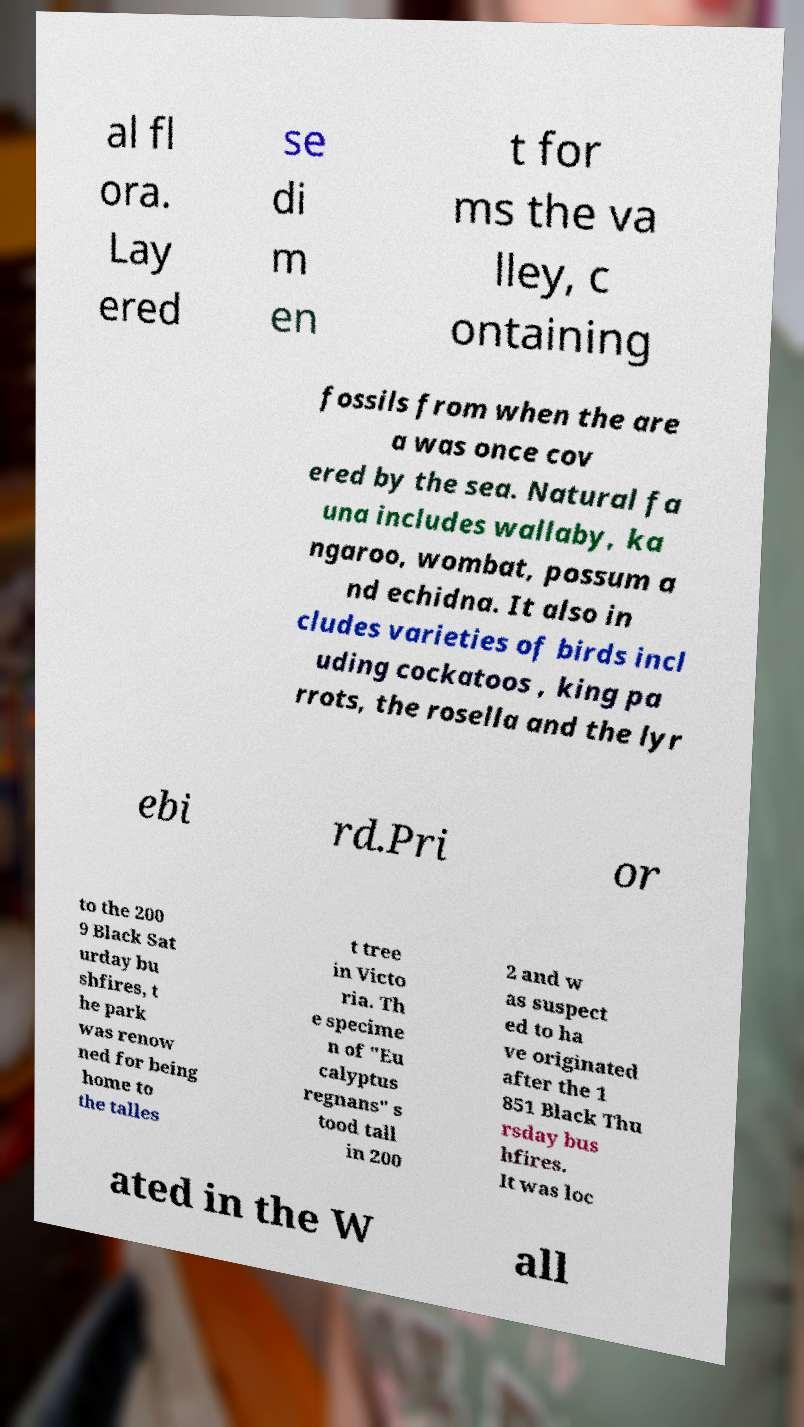Could you assist in decoding the text presented in this image and type it out clearly? al fl ora. Lay ered se di m en t for ms the va lley, c ontaining fossils from when the are a was once cov ered by the sea. Natural fa una includes wallaby, ka ngaroo, wombat, possum a nd echidna. It also in cludes varieties of birds incl uding cockatoos , king pa rrots, the rosella and the lyr ebi rd.Pri or to the 200 9 Black Sat urday bu shfires, t he park was renow ned for being home to the talles t tree in Victo ria. Th e specime n of "Eu calyptus regnans" s tood tall in 200 2 and w as suspect ed to ha ve originated after the 1 851 Black Thu rsday bus hfires. It was loc ated in the W all 